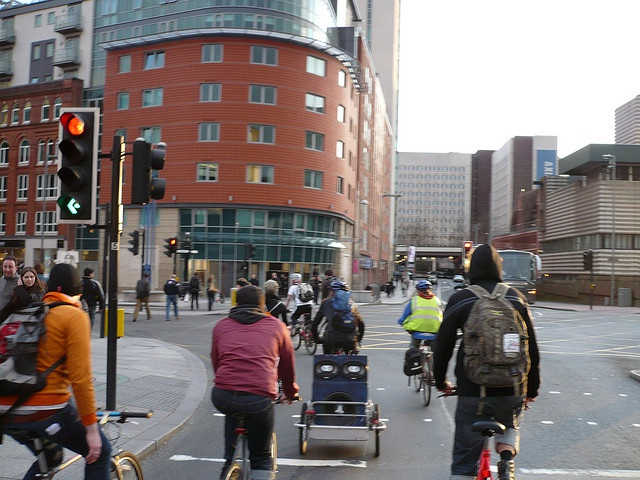Describe the objects in this image and their specific colors. I can see people in gray, black, and darkgray tones, people in gray, black, maroon, and brown tones, people in gray, black, brown, maroon, and purple tones, bicycle in gray and black tones, and backpack in gray and black tones in this image. 